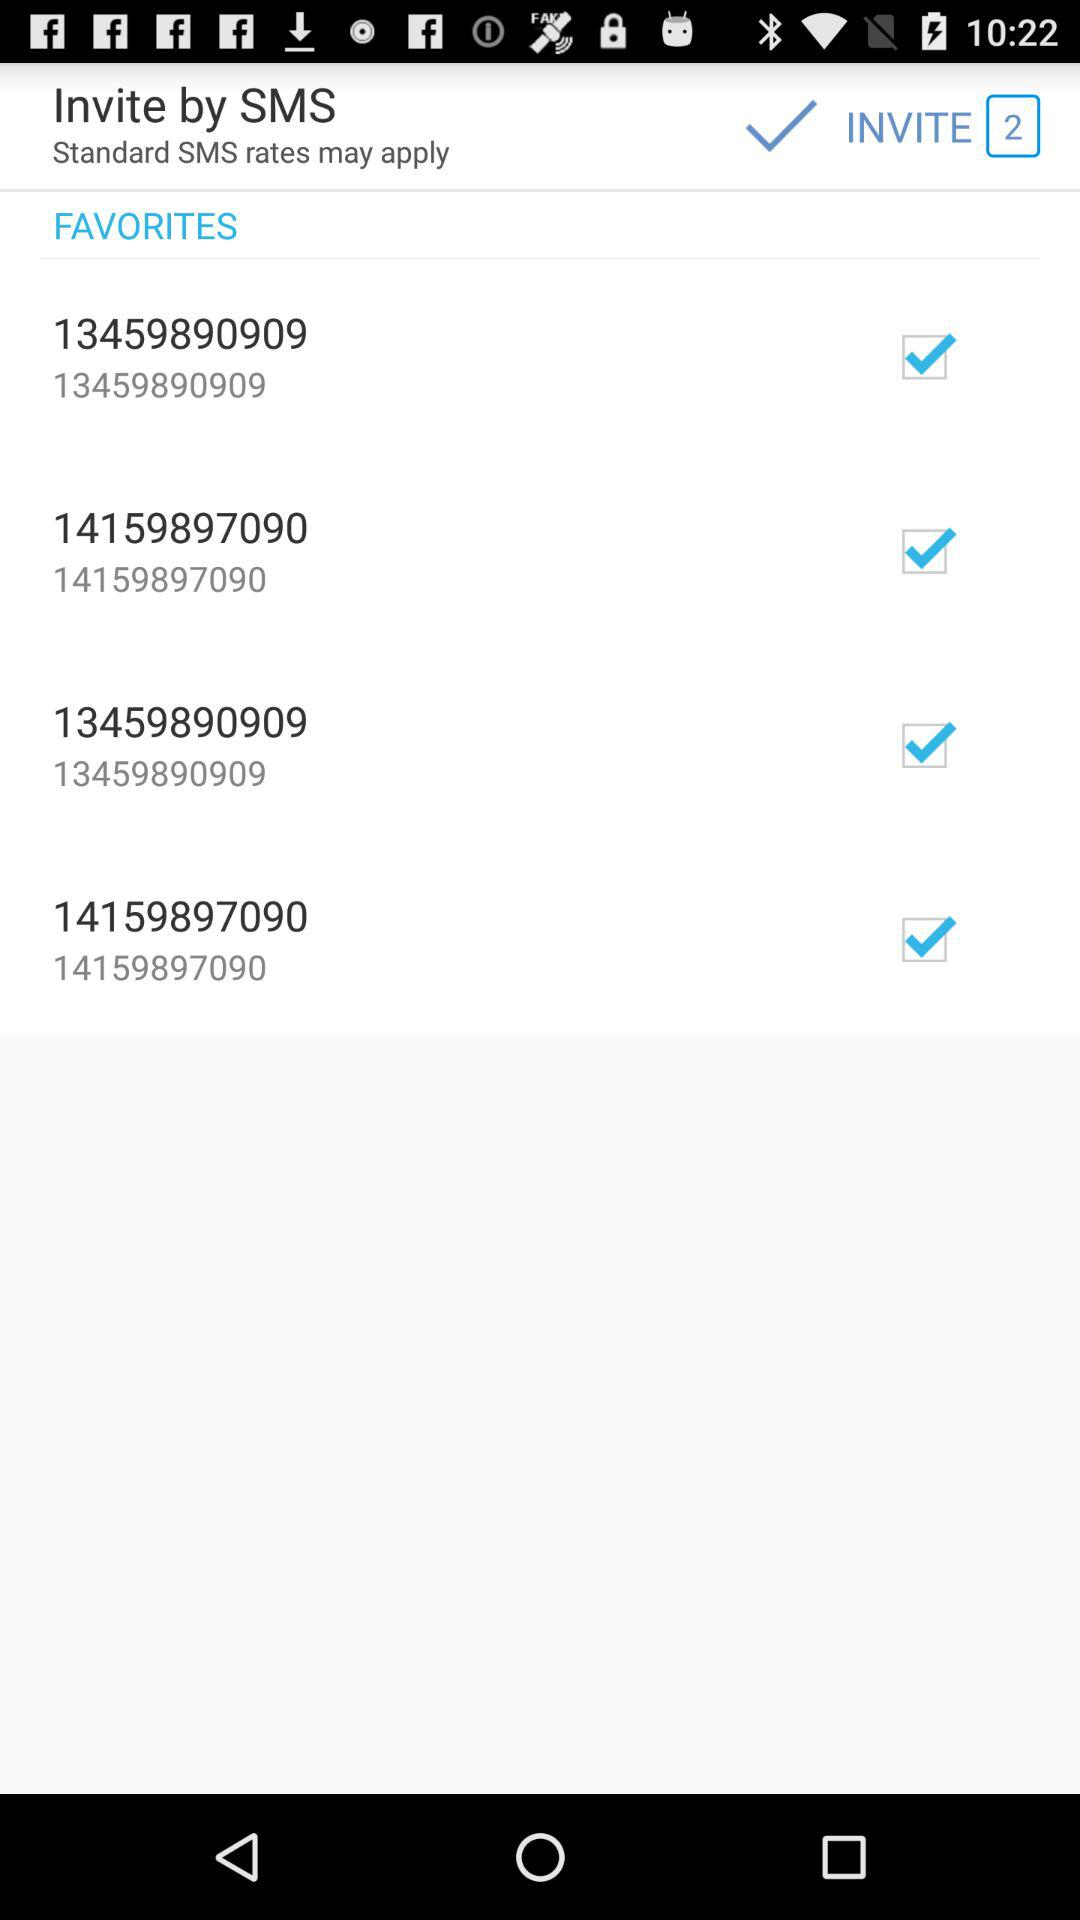How many invites are there? There are 2 invites. 